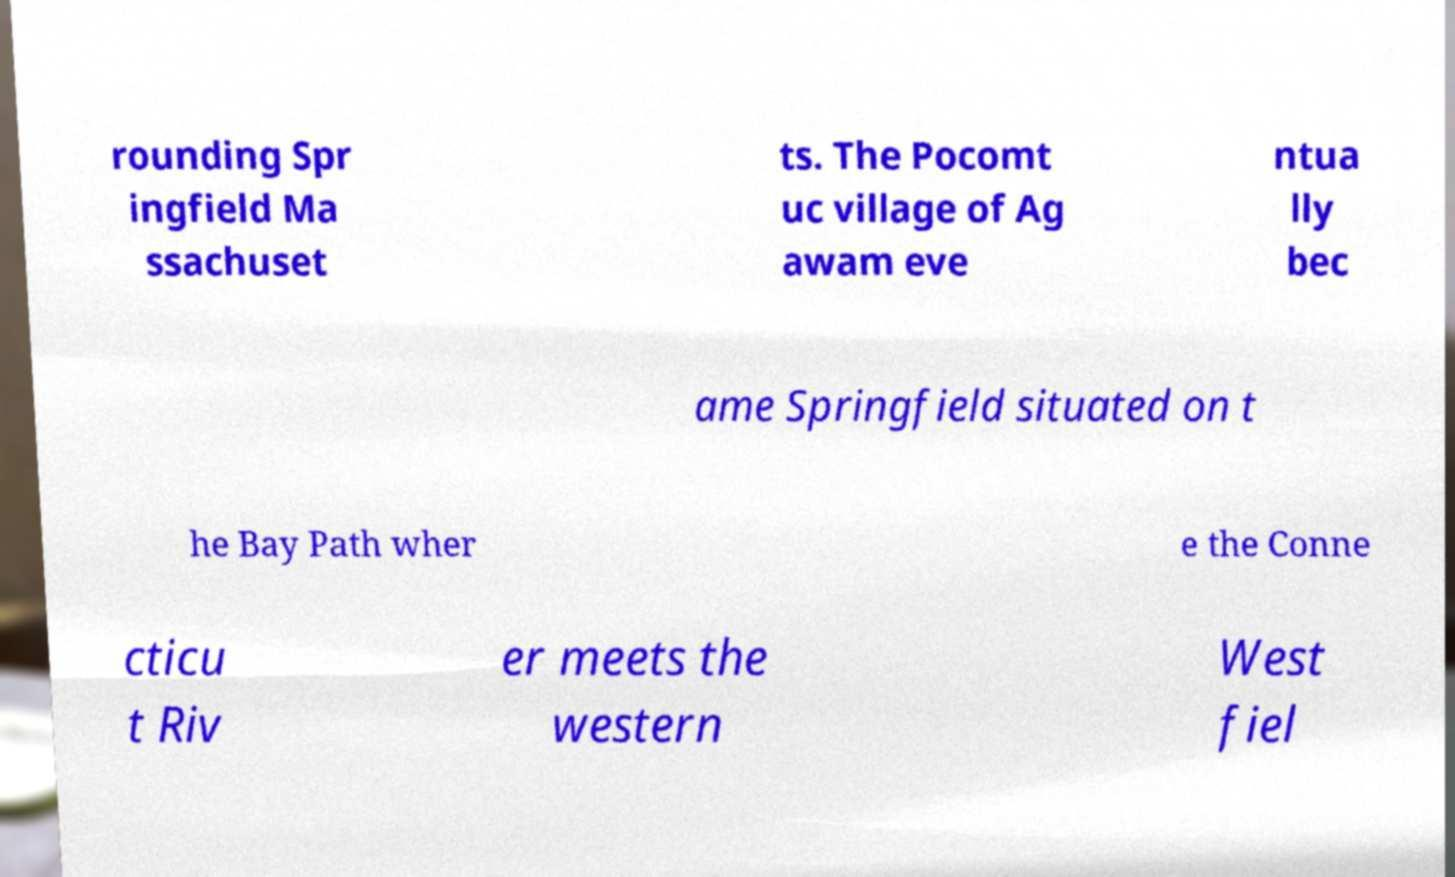Could you extract and type out the text from this image? rounding Spr ingfield Ma ssachuset ts. The Pocomt uc village of Ag awam eve ntua lly bec ame Springfield situated on t he Bay Path wher e the Conne cticu t Riv er meets the western West fiel 